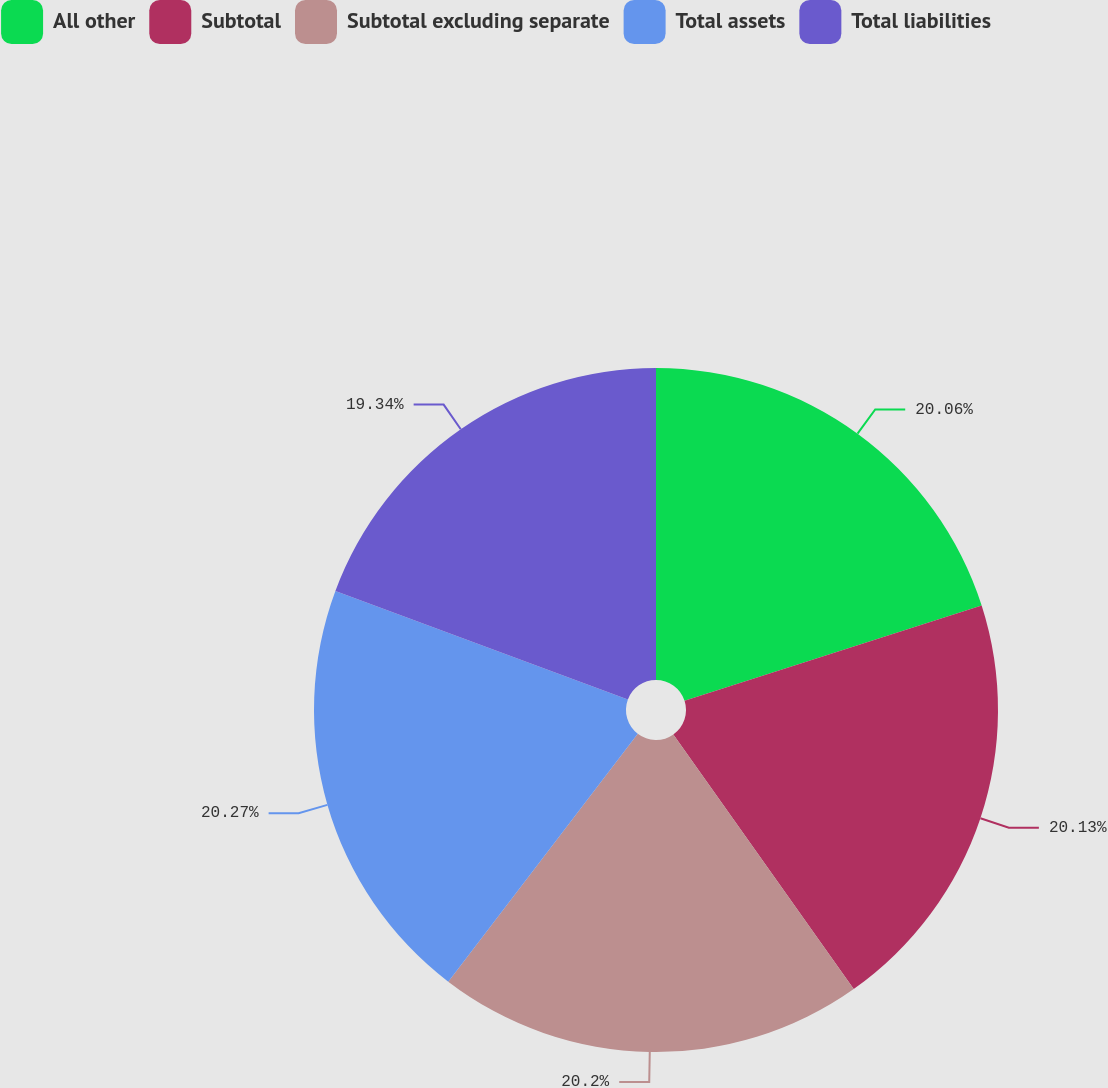Convert chart. <chart><loc_0><loc_0><loc_500><loc_500><pie_chart><fcel>All other<fcel>Subtotal<fcel>Subtotal excluding separate<fcel>Total assets<fcel>Total liabilities<nl><fcel>20.06%<fcel>20.13%<fcel>20.2%<fcel>20.27%<fcel>19.34%<nl></chart> 